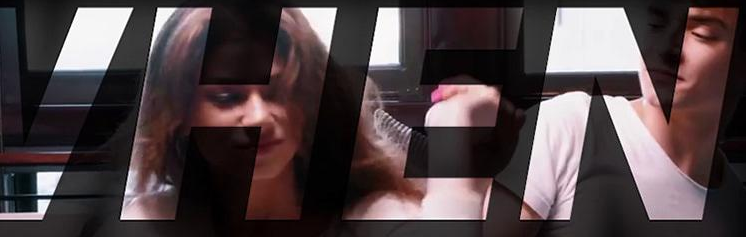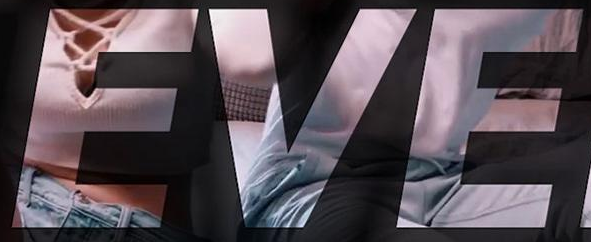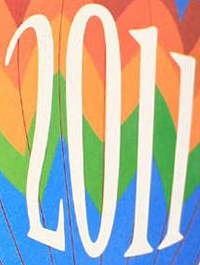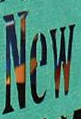What words can you see in these images in sequence, separated by a semicolon? VHEN; EVE; 2011; New 